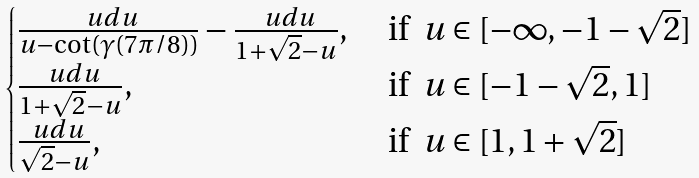Convert formula to latex. <formula><loc_0><loc_0><loc_500><loc_500>\begin{cases} \frac { \ u d u } { u - \cot ( \gamma ( 7 \pi / 8 ) ) } - \frac { \ u d u } { 1 + \sqrt { 2 } - u } , & \text {  if } \ u \in [ - \infty , - 1 - \sqrt { 2 } ] \\ \frac { \ u d u } { 1 + \sqrt { 2 } - u } , & \text {  if } \ u \in [ - 1 - \sqrt { 2 } , 1 ] \\ \frac { \ u d u } { \sqrt { 2 } - u } , & \text {  if } \ u \in [ 1 , 1 + \sqrt { 2 } ] \end{cases}</formula> 